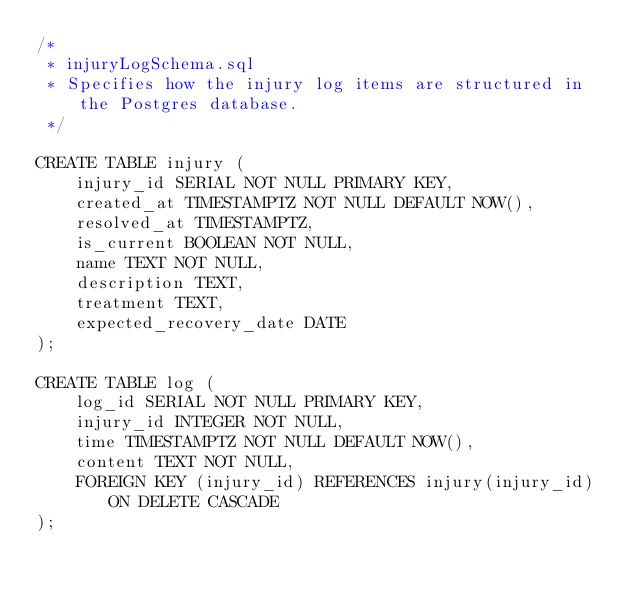<code> <loc_0><loc_0><loc_500><loc_500><_SQL_>/*
 * injuryLogSchema.sql
 * Specifies how the injury log items are structured in the Postgres database.
 */

CREATE TABLE injury (
    injury_id SERIAL NOT NULL PRIMARY KEY,
    created_at TIMESTAMPTZ NOT NULL DEFAULT NOW(),
    resolved_at TIMESTAMPTZ,
    is_current BOOLEAN NOT NULL,
    name TEXT NOT NULL,
    description TEXT,
    treatment TEXT,
    expected_recovery_date DATE
);

CREATE TABLE log (
    log_id SERIAL NOT NULL PRIMARY KEY,
    injury_id INTEGER NOT NULL,
    time TIMESTAMPTZ NOT NULL DEFAULT NOW(),
    content TEXT NOT NULL,
    FOREIGN KEY (injury_id) REFERENCES injury(injury_id) ON DELETE CASCADE
);</code> 